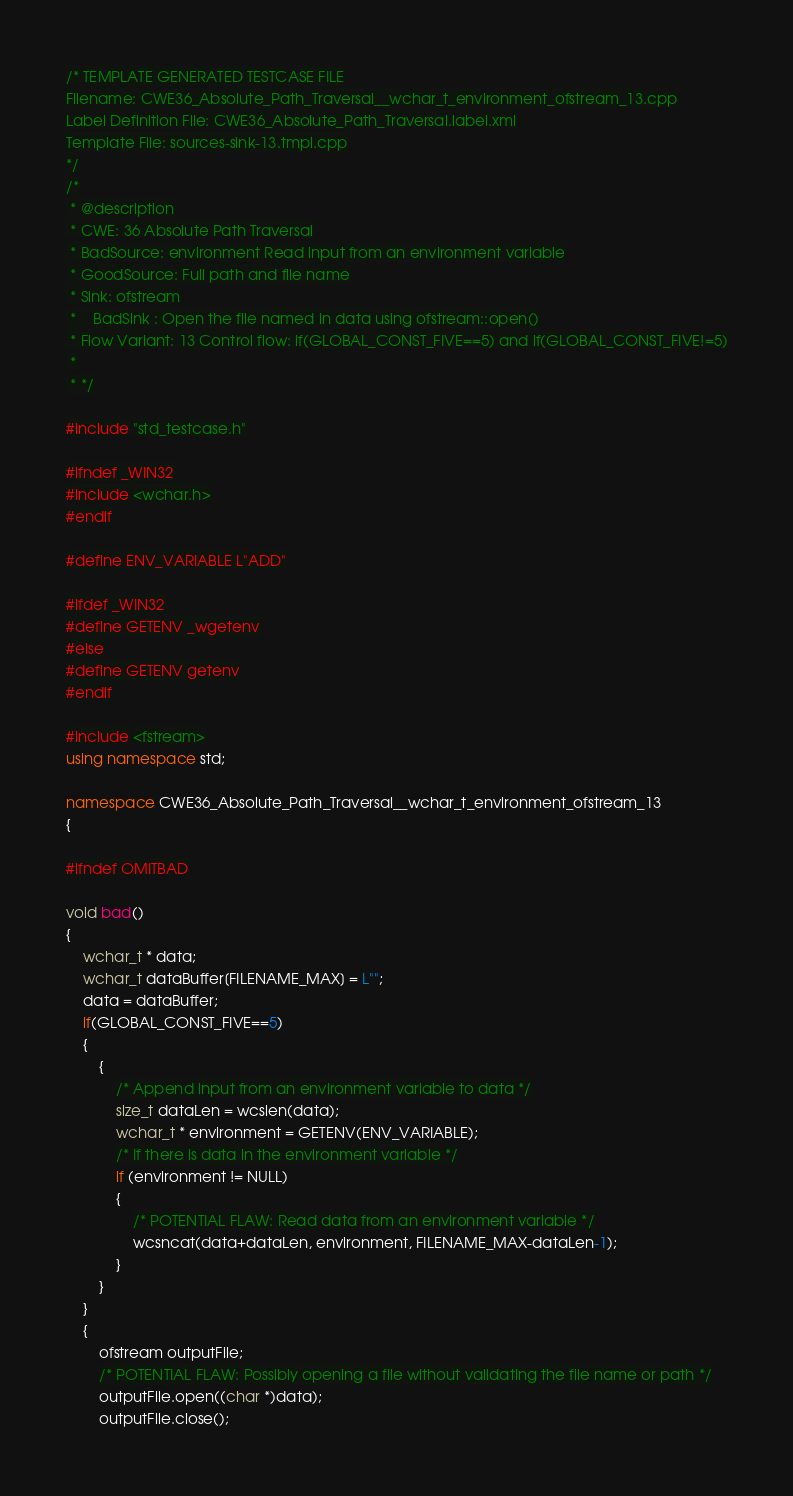<code> <loc_0><loc_0><loc_500><loc_500><_C++_>/* TEMPLATE GENERATED TESTCASE FILE
Filename: CWE36_Absolute_Path_Traversal__wchar_t_environment_ofstream_13.cpp
Label Definition File: CWE36_Absolute_Path_Traversal.label.xml
Template File: sources-sink-13.tmpl.cpp
*/
/*
 * @description
 * CWE: 36 Absolute Path Traversal
 * BadSource: environment Read input from an environment variable
 * GoodSource: Full path and file name
 * Sink: ofstream
 *    BadSink : Open the file named in data using ofstream::open()
 * Flow Variant: 13 Control flow: if(GLOBAL_CONST_FIVE==5) and if(GLOBAL_CONST_FIVE!=5)
 *
 * */

#include "std_testcase.h"

#ifndef _WIN32
#include <wchar.h>
#endif

#define ENV_VARIABLE L"ADD"

#ifdef _WIN32
#define GETENV _wgetenv
#else
#define GETENV getenv
#endif

#include <fstream>
using namespace std;

namespace CWE36_Absolute_Path_Traversal__wchar_t_environment_ofstream_13
{

#ifndef OMITBAD

void bad()
{
    wchar_t * data;
    wchar_t dataBuffer[FILENAME_MAX] = L"";
    data = dataBuffer;
    if(GLOBAL_CONST_FIVE==5)
    {
        {
            /* Append input from an environment variable to data */
            size_t dataLen = wcslen(data);
            wchar_t * environment = GETENV(ENV_VARIABLE);
            /* If there is data in the environment variable */
            if (environment != NULL)
            {
                /* POTENTIAL FLAW: Read data from an environment variable */
                wcsncat(data+dataLen, environment, FILENAME_MAX-dataLen-1);
            }
        }
    }
    {
        ofstream outputFile;
        /* POTENTIAL FLAW: Possibly opening a file without validating the file name or path */
        outputFile.open((char *)data);
        outputFile.close();</code> 